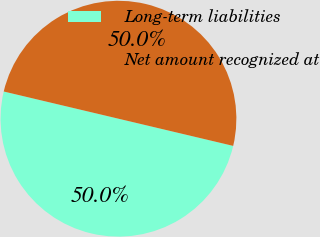<chart> <loc_0><loc_0><loc_500><loc_500><pie_chart><fcel>Long-term liabilities<fcel>Net amount recognized at<nl><fcel>50.0%<fcel>50.0%<nl></chart> 